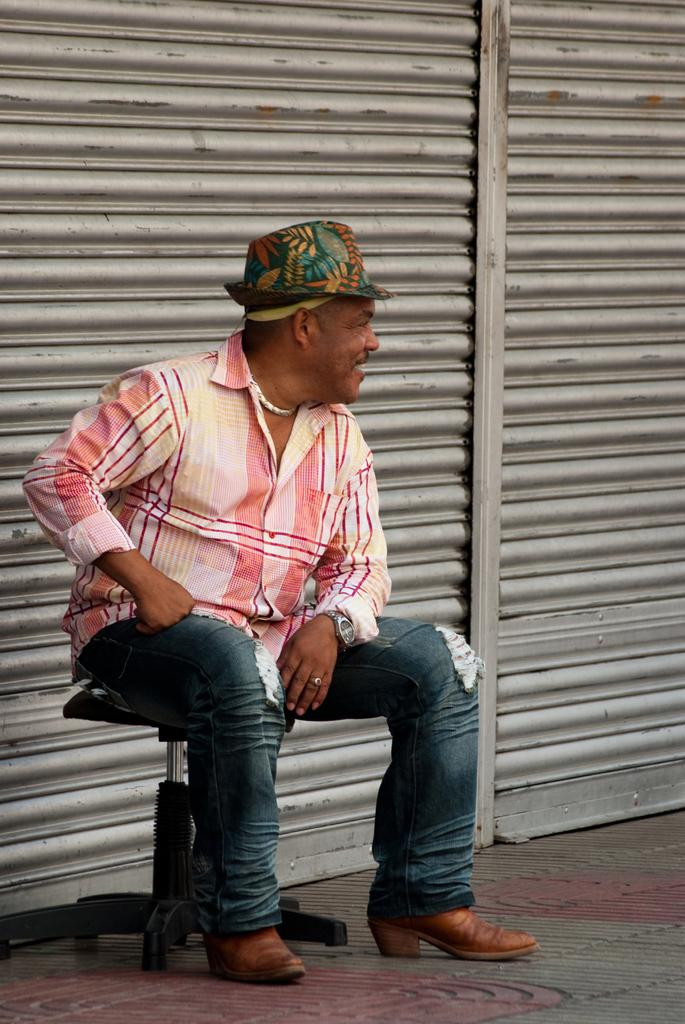What is the man in the foreground of the image doing? The man is sitting on a chair in the foreground of the image. What can be seen in the background of the image? There are shutters in the background of the image. What is at the bottom of the image? There is a walkway at the bottom of the image. What type of glass is the man drinking from in the image? There is no glass or indication of drinking in the image; the man is simply sitting on a chair. 